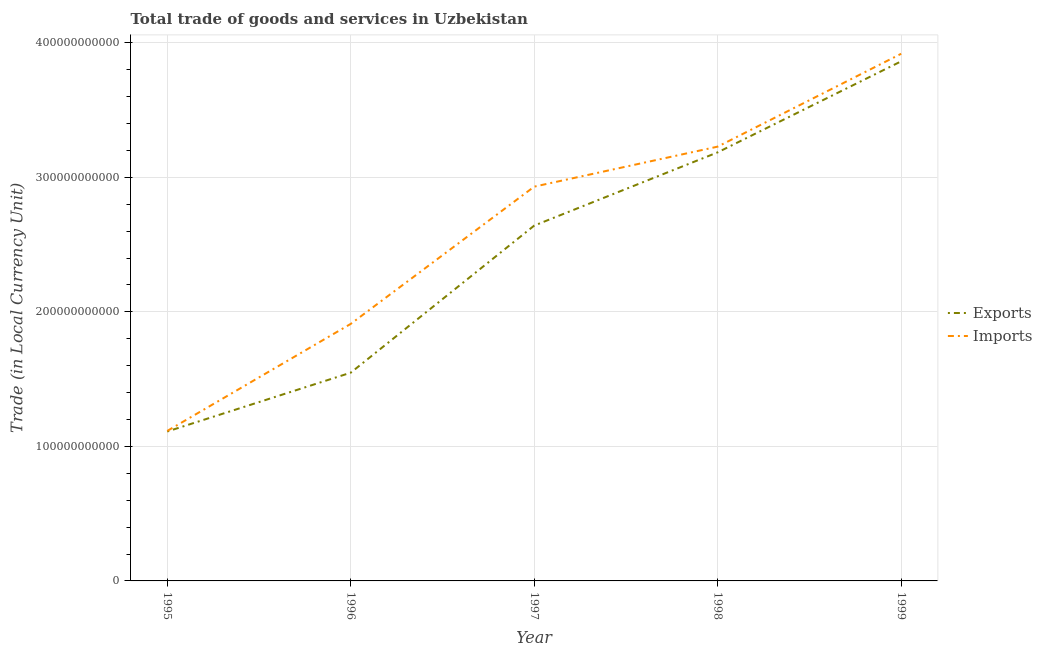How many different coloured lines are there?
Offer a terse response. 2. Does the line corresponding to imports of goods and services intersect with the line corresponding to export of goods and services?
Provide a succinct answer. No. What is the imports of goods and services in 1995?
Your answer should be compact. 1.11e+11. Across all years, what is the maximum export of goods and services?
Your response must be concise. 3.86e+11. Across all years, what is the minimum export of goods and services?
Ensure brevity in your answer.  1.11e+11. In which year was the export of goods and services minimum?
Offer a very short reply. 1995. What is the total export of goods and services in the graph?
Your response must be concise. 1.23e+12. What is the difference between the imports of goods and services in 1995 and that in 1998?
Your response must be concise. -2.11e+11. What is the difference between the imports of goods and services in 1996 and the export of goods and services in 1997?
Provide a succinct answer. -7.31e+1. What is the average export of goods and services per year?
Your response must be concise. 2.47e+11. In the year 1999, what is the difference between the export of goods and services and imports of goods and services?
Provide a short and direct response. -5.61e+09. In how many years, is the imports of goods and services greater than 140000000000 LCU?
Your answer should be very brief. 4. What is the ratio of the imports of goods and services in 1995 to that in 1997?
Keep it short and to the point. 0.38. Is the difference between the export of goods and services in 1998 and 1999 greater than the difference between the imports of goods and services in 1998 and 1999?
Your answer should be compact. Yes. What is the difference between the highest and the second highest export of goods and services?
Provide a short and direct response. 6.77e+1. What is the difference between the highest and the lowest export of goods and services?
Offer a very short reply. 2.75e+11. Is the sum of the export of goods and services in 1998 and 1999 greater than the maximum imports of goods and services across all years?
Ensure brevity in your answer.  Yes. Is the imports of goods and services strictly greater than the export of goods and services over the years?
Your answer should be very brief. Yes. How many years are there in the graph?
Your answer should be compact. 5. What is the difference between two consecutive major ticks on the Y-axis?
Offer a very short reply. 1.00e+11. Does the graph contain any zero values?
Make the answer very short. No. Does the graph contain grids?
Your response must be concise. Yes. What is the title of the graph?
Offer a very short reply. Total trade of goods and services in Uzbekistan. What is the label or title of the Y-axis?
Keep it short and to the point. Trade (in Local Currency Unit). What is the Trade (in Local Currency Unit) in Exports in 1995?
Provide a succinct answer. 1.11e+11. What is the Trade (in Local Currency Unit) in Imports in 1995?
Offer a very short reply. 1.11e+11. What is the Trade (in Local Currency Unit) of Exports in 1996?
Provide a short and direct response. 1.55e+11. What is the Trade (in Local Currency Unit) of Imports in 1996?
Provide a succinct answer. 1.91e+11. What is the Trade (in Local Currency Unit) of Exports in 1997?
Provide a short and direct response. 2.64e+11. What is the Trade (in Local Currency Unit) in Imports in 1997?
Make the answer very short. 2.93e+11. What is the Trade (in Local Currency Unit) of Exports in 1998?
Keep it short and to the point. 3.19e+11. What is the Trade (in Local Currency Unit) in Imports in 1998?
Provide a short and direct response. 3.23e+11. What is the Trade (in Local Currency Unit) of Exports in 1999?
Ensure brevity in your answer.  3.86e+11. What is the Trade (in Local Currency Unit) of Imports in 1999?
Your answer should be compact. 3.92e+11. Across all years, what is the maximum Trade (in Local Currency Unit) of Exports?
Your answer should be compact. 3.86e+11. Across all years, what is the maximum Trade (in Local Currency Unit) in Imports?
Your response must be concise. 3.92e+11. Across all years, what is the minimum Trade (in Local Currency Unit) in Exports?
Your response must be concise. 1.11e+11. Across all years, what is the minimum Trade (in Local Currency Unit) of Imports?
Keep it short and to the point. 1.11e+11. What is the total Trade (in Local Currency Unit) of Exports in the graph?
Your answer should be compact. 1.23e+12. What is the total Trade (in Local Currency Unit) in Imports in the graph?
Give a very brief answer. 1.31e+12. What is the difference between the Trade (in Local Currency Unit) in Exports in 1995 and that in 1996?
Your response must be concise. -4.37e+1. What is the difference between the Trade (in Local Currency Unit) in Imports in 1995 and that in 1996?
Offer a very short reply. -7.96e+1. What is the difference between the Trade (in Local Currency Unit) of Exports in 1995 and that in 1997?
Provide a short and direct response. -1.53e+11. What is the difference between the Trade (in Local Currency Unit) of Imports in 1995 and that in 1997?
Provide a succinct answer. -1.82e+11. What is the difference between the Trade (in Local Currency Unit) in Exports in 1995 and that in 1998?
Make the answer very short. -2.08e+11. What is the difference between the Trade (in Local Currency Unit) of Imports in 1995 and that in 1998?
Make the answer very short. -2.11e+11. What is the difference between the Trade (in Local Currency Unit) of Exports in 1995 and that in 1999?
Offer a very short reply. -2.75e+11. What is the difference between the Trade (in Local Currency Unit) in Imports in 1995 and that in 1999?
Give a very brief answer. -2.80e+11. What is the difference between the Trade (in Local Currency Unit) in Exports in 1996 and that in 1997?
Offer a very short reply. -1.09e+11. What is the difference between the Trade (in Local Currency Unit) of Imports in 1996 and that in 1997?
Your response must be concise. -1.02e+11. What is the difference between the Trade (in Local Currency Unit) of Exports in 1996 and that in 1998?
Provide a short and direct response. -1.64e+11. What is the difference between the Trade (in Local Currency Unit) in Imports in 1996 and that in 1998?
Ensure brevity in your answer.  -1.32e+11. What is the difference between the Trade (in Local Currency Unit) in Exports in 1996 and that in 1999?
Your response must be concise. -2.31e+11. What is the difference between the Trade (in Local Currency Unit) of Imports in 1996 and that in 1999?
Keep it short and to the point. -2.01e+11. What is the difference between the Trade (in Local Currency Unit) of Exports in 1997 and that in 1998?
Offer a terse response. -5.44e+1. What is the difference between the Trade (in Local Currency Unit) in Imports in 1997 and that in 1998?
Your answer should be compact. -2.97e+1. What is the difference between the Trade (in Local Currency Unit) in Exports in 1997 and that in 1999?
Offer a very short reply. -1.22e+11. What is the difference between the Trade (in Local Currency Unit) of Imports in 1997 and that in 1999?
Offer a terse response. -9.88e+1. What is the difference between the Trade (in Local Currency Unit) of Exports in 1998 and that in 1999?
Keep it short and to the point. -6.77e+1. What is the difference between the Trade (in Local Currency Unit) in Imports in 1998 and that in 1999?
Offer a very short reply. -6.90e+1. What is the difference between the Trade (in Local Currency Unit) in Exports in 1995 and the Trade (in Local Currency Unit) in Imports in 1996?
Offer a very short reply. -8.00e+1. What is the difference between the Trade (in Local Currency Unit) of Exports in 1995 and the Trade (in Local Currency Unit) of Imports in 1997?
Provide a short and direct response. -1.82e+11. What is the difference between the Trade (in Local Currency Unit) of Exports in 1995 and the Trade (in Local Currency Unit) of Imports in 1998?
Your response must be concise. -2.12e+11. What is the difference between the Trade (in Local Currency Unit) in Exports in 1995 and the Trade (in Local Currency Unit) in Imports in 1999?
Make the answer very short. -2.81e+11. What is the difference between the Trade (in Local Currency Unit) in Exports in 1996 and the Trade (in Local Currency Unit) in Imports in 1997?
Your response must be concise. -1.38e+11. What is the difference between the Trade (in Local Currency Unit) in Exports in 1996 and the Trade (in Local Currency Unit) in Imports in 1998?
Provide a succinct answer. -1.68e+11. What is the difference between the Trade (in Local Currency Unit) of Exports in 1996 and the Trade (in Local Currency Unit) of Imports in 1999?
Provide a short and direct response. -2.37e+11. What is the difference between the Trade (in Local Currency Unit) of Exports in 1997 and the Trade (in Local Currency Unit) of Imports in 1998?
Provide a short and direct response. -5.87e+1. What is the difference between the Trade (in Local Currency Unit) of Exports in 1997 and the Trade (in Local Currency Unit) of Imports in 1999?
Offer a very short reply. -1.28e+11. What is the difference between the Trade (in Local Currency Unit) of Exports in 1998 and the Trade (in Local Currency Unit) of Imports in 1999?
Give a very brief answer. -7.33e+1. What is the average Trade (in Local Currency Unit) in Exports per year?
Provide a succinct answer. 2.47e+11. What is the average Trade (in Local Currency Unit) in Imports per year?
Give a very brief answer. 2.62e+11. In the year 1995, what is the difference between the Trade (in Local Currency Unit) of Exports and Trade (in Local Currency Unit) of Imports?
Your answer should be compact. -4.17e+08. In the year 1996, what is the difference between the Trade (in Local Currency Unit) in Exports and Trade (in Local Currency Unit) in Imports?
Ensure brevity in your answer.  -3.63e+1. In the year 1997, what is the difference between the Trade (in Local Currency Unit) of Exports and Trade (in Local Currency Unit) of Imports?
Make the answer very short. -2.90e+1. In the year 1998, what is the difference between the Trade (in Local Currency Unit) in Exports and Trade (in Local Currency Unit) in Imports?
Offer a terse response. -4.25e+09. In the year 1999, what is the difference between the Trade (in Local Currency Unit) of Exports and Trade (in Local Currency Unit) of Imports?
Ensure brevity in your answer.  -5.61e+09. What is the ratio of the Trade (in Local Currency Unit) of Exports in 1995 to that in 1996?
Your answer should be compact. 0.72. What is the ratio of the Trade (in Local Currency Unit) of Imports in 1995 to that in 1996?
Ensure brevity in your answer.  0.58. What is the ratio of the Trade (in Local Currency Unit) in Exports in 1995 to that in 1997?
Make the answer very short. 0.42. What is the ratio of the Trade (in Local Currency Unit) of Imports in 1995 to that in 1997?
Provide a short and direct response. 0.38. What is the ratio of the Trade (in Local Currency Unit) in Exports in 1995 to that in 1998?
Provide a succinct answer. 0.35. What is the ratio of the Trade (in Local Currency Unit) of Imports in 1995 to that in 1998?
Give a very brief answer. 0.35. What is the ratio of the Trade (in Local Currency Unit) of Exports in 1995 to that in 1999?
Make the answer very short. 0.29. What is the ratio of the Trade (in Local Currency Unit) in Imports in 1995 to that in 1999?
Your answer should be compact. 0.28. What is the ratio of the Trade (in Local Currency Unit) of Exports in 1996 to that in 1997?
Keep it short and to the point. 0.59. What is the ratio of the Trade (in Local Currency Unit) of Imports in 1996 to that in 1997?
Make the answer very short. 0.65. What is the ratio of the Trade (in Local Currency Unit) of Exports in 1996 to that in 1998?
Your answer should be compact. 0.49. What is the ratio of the Trade (in Local Currency Unit) of Imports in 1996 to that in 1998?
Ensure brevity in your answer.  0.59. What is the ratio of the Trade (in Local Currency Unit) in Exports in 1996 to that in 1999?
Your answer should be very brief. 0.4. What is the ratio of the Trade (in Local Currency Unit) in Imports in 1996 to that in 1999?
Provide a succinct answer. 0.49. What is the ratio of the Trade (in Local Currency Unit) of Exports in 1997 to that in 1998?
Offer a very short reply. 0.83. What is the ratio of the Trade (in Local Currency Unit) in Imports in 1997 to that in 1998?
Offer a terse response. 0.91. What is the ratio of the Trade (in Local Currency Unit) in Exports in 1997 to that in 1999?
Keep it short and to the point. 0.68. What is the ratio of the Trade (in Local Currency Unit) of Imports in 1997 to that in 1999?
Provide a short and direct response. 0.75. What is the ratio of the Trade (in Local Currency Unit) of Exports in 1998 to that in 1999?
Your answer should be compact. 0.82. What is the ratio of the Trade (in Local Currency Unit) in Imports in 1998 to that in 1999?
Give a very brief answer. 0.82. What is the difference between the highest and the second highest Trade (in Local Currency Unit) in Exports?
Offer a very short reply. 6.77e+1. What is the difference between the highest and the second highest Trade (in Local Currency Unit) in Imports?
Keep it short and to the point. 6.90e+1. What is the difference between the highest and the lowest Trade (in Local Currency Unit) of Exports?
Ensure brevity in your answer.  2.75e+11. What is the difference between the highest and the lowest Trade (in Local Currency Unit) of Imports?
Provide a short and direct response. 2.80e+11. 